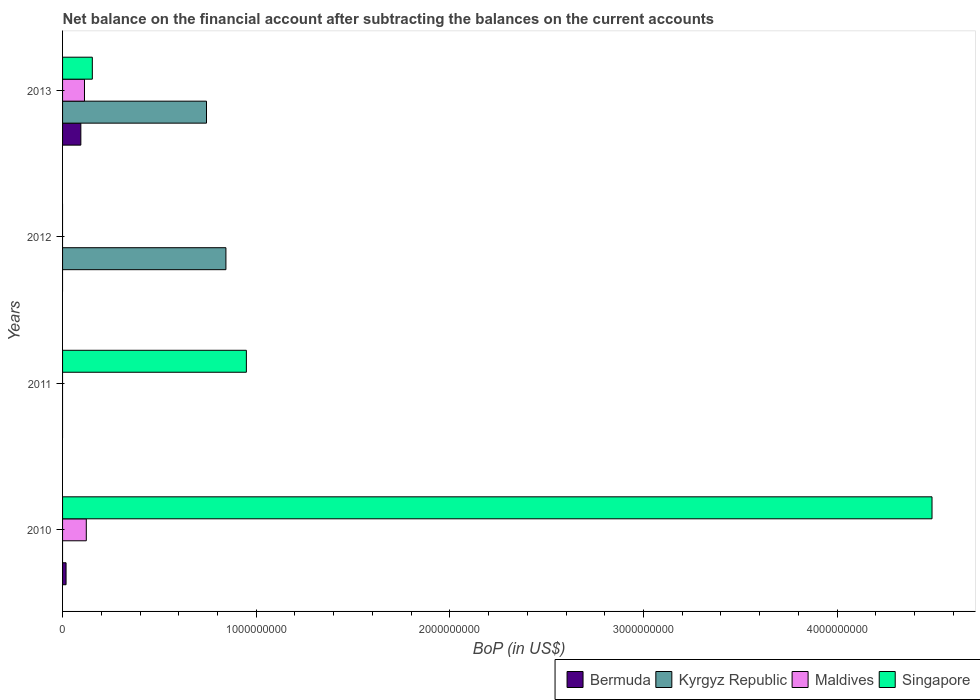How many different coloured bars are there?
Ensure brevity in your answer.  4. Are the number of bars per tick equal to the number of legend labels?
Offer a very short reply. No. How many bars are there on the 1st tick from the bottom?
Make the answer very short. 3. What is the label of the 3rd group of bars from the top?
Your answer should be very brief. 2011. What is the Balance of Payments in Kyrgyz Republic in 2013?
Keep it short and to the point. 7.43e+08. Across all years, what is the maximum Balance of Payments in Singapore?
Give a very brief answer. 4.49e+09. In which year was the Balance of Payments in Singapore maximum?
Offer a very short reply. 2010. What is the total Balance of Payments in Bermuda in the graph?
Provide a succinct answer. 1.12e+08. What is the difference between the Balance of Payments in Kyrgyz Republic in 2012 and that in 2013?
Give a very brief answer. 1.00e+08. What is the difference between the Balance of Payments in Maldives in 2010 and the Balance of Payments in Bermuda in 2011?
Offer a very short reply. 1.23e+08. What is the average Balance of Payments in Maldives per year?
Offer a terse response. 5.89e+07. In the year 2013, what is the difference between the Balance of Payments in Singapore and Balance of Payments in Kyrgyz Republic?
Offer a very short reply. -5.90e+08. In how many years, is the Balance of Payments in Maldives greater than 2200000000 US$?
Offer a terse response. 0. What is the ratio of the Balance of Payments in Singapore in 2011 to that in 2013?
Offer a terse response. 6.18. What is the difference between the highest and the second highest Balance of Payments in Singapore?
Make the answer very short. 3.54e+09. What is the difference between the highest and the lowest Balance of Payments in Singapore?
Ensure brevity in your answer.  4.49e+09. In how many years, is the Balance of Payments in Kyrgyz Republic greater than the average Balance of Payments in Kyrgyz Republic taken over all years?
Offer a very short reply. 2. Is it the case that in every year, the sum of the Balance of Payments in Bermuda and Balance of Payments in Maldives is greater than the sum of Balance of Payments in Singapore and Balance of Payments in Kyrgyz Republic?
Your answer should be very brief. No. Are all the bars in the graph horizontal?
Make the answer very short. Yes. Are the values on the major ticks of X-axis written in scientific E-notation?
Ensure brevity in your answer.  No. Does the graph contain grids?
Ensure brevity in your answer.  No. Where does the legend appear in the graph?
Your answer should be very brief. Bottom right. How many legend labels are there?
Keep it short and to the point. 4. How are the legend labels stacked?
Offer a very short reply. Horizontal. What is the title of the graph?
Keep it short and to the point. Net balance on the financial account after subtracting the balances on the current accounts. What is the label or title of the X-axis?
Provide a succinct answer. BoP (in US$). What is the label or title of the Y-axis?
Offer a very short reply. Years. What is the BoP (in US$) in Bermuda in 2010?
Offer a terse response. 1.80e+07. What is the BoP (in US$) of Maldives in 2010?
Offer a very short reply. 1.23e+08. What is the BoP (in US$) in Singapore in 2010?
Give a very brief answer. 4.49e+09. What is the BoP (in US$) in Kyrgyz Republic in 2011?
Offer a terse response. 0. What is the BoP (in US$) in Maldives in 2011?
Make the answer very short. 0. What is the BoP (in US$) of Singapore in 2011?
Make the answer very short. 9.49e+08. What is the BoP (in US$) of Bermuda in 2012?
Offer a terse response. 0. What is the BoP (in US$) in Kyrgyz Republic in 2012?
Your answer should be very brief. 8.44e+08. What is the BoP (in US$) of Maldives in 2012?
Your answer should be very brief. 0. What is the BoP (in US$) of Singapore in 2012?
Give a very brief answer. 0. What is the BoP (in US$) in Bermuda in 2013?
Give a very brief answer. 9.44e+07. What is the BoP (in US$) in Kyrgyz Republic in 2013?
Your answer should be compact. 7.43e+08. What is the BoP (in US$) of Maldives in 2013?
Your answer should be compact. 1.13e+08. What is the BoP (in US$) in Singapore in 2013?
Your response must be concise. 1.54e+08. Across all years, what is the maximum BoP (in US$) in Bermuda?
Your response must be concise. 9.44e+07. Across all years, what is the maximum BoP (in US$) in Kyrgyz Republic?
Your answer should be compact. 8.44e+08. Across all years, what is the maximum BoP (in US$) in Maldives?
Give a very brief answer. 1.23e+08. Across all years, what is the maximum BoP (in US$) of Singapore?
Offer a very short reply. 4.49e+09. Across all years, what is the minimum BoP (in US$) in Kyrgyz Republic?
Keep it short and to the point. 0. What is the total BoP (in US$) of Bermuda in the graph?
Offer a very short reply. 1.12e+08. What is the total BoP (in US$) of Kyrgyz Republic in the graph?
Make the answer very short. 1.59e+09. What is the total BoP (in US$) in Maldives in the graph?
Provide a succinct answer. 2.36e+08. What is the total BoP (in US$) of Singapore in the graph?
Give a very brief answer. 5.59e+09. What is the difference between the BoP (in US$) of Singapore in 2010 and that in 2011?
Ensure brevity in your answer.  3.54e+09. What is the difference between the BoP (in US$) in Bermuda in 2010 and that in 2013?
Give a very brief answer. -7.64e+07. What is the difference between the BoP (in US$) in Maldives in 2010 and that in 2013?
Your answer should be very brief. 9.42e+06. What is the difference between the BoP (in US$) of Singapore in 2010 and that in 2013?
Provide a short and direct response. 4.34e+09. What is the difference between the BoP (in US$) of Singapore in 2011 and that in 2013?
Ensure brevity in your answer.  7.96e+08. What is the difference between the BoP (in US$) in Kyrgyz Republic in 2012 and that in 2013?
Offer a very short reply. 1.00e+08. What is the difference between the BoP (in US$) of Bermuda in 2010 and the BoP (in US$) of Singapore in 2011?
Your response must be concise. -9.31e+08. What is the difference between the BoP (in US$) in Maldives in 2010 and the BoP (in US$) in Singapore in 2011?
Your answer should be very brief. -8.27e+08. What is the difference between the BoP (in US$) of Bermuda in 2010 and the BoP (in US$) of Kyrgyz Republic in 2012?
Keep it short and to the point. -8.26e+08. What is the difference between the BoP (in US$) of Bermuda in 2010 and the BoP (in US$) of Kyrgyz Republic in 2013?
Your answer should be very brief. -7.25e+08. What is the difference between the BoP (in US$) of Bermuda in 2010 and the BoP (in US$) of Maldives in 2013?
Offer a very short reply. -9.51e+07. What is the difference between the BoP (in US$) in Bermuda in 2010 and the BoP (in US$) in Singapore in 2013?
Provide a succinct answer. -1.36e+08. What is the difference between the BoP (in US$) of Maldives in 2010 and the BoP (in US$) of Singapore in 2013?
Give a very brief answer. -3.11e+07. What is the difference between the BoP (in US$) in Kyrgyz Republic in 2012 and the BoP (in US$) in Maldives in 2013?
Make the answer very short. 7.30e+08. What is the difference between the BoP (in US$) in Kyrgyz Republic in 2012 and the BoP (in US$) in Singapore in 2013?
Make the answer very short. 6.90e+08. What is the average BoP (in US$) in Bermuda per year?
Ensure brevity in your answer.  2.81e+07. What is the average BoP (in US$) of Kyrgyz Republic per year?
Make the answer very short. 3.97e+08. What is the average BoP (in US$) in Maldives per year?
Your response must be concise. 5.89e+07. What is the average BoP (in US$) of Singapore per year?
Provide a succinct answer. 1.40e+09. In the year 2010, what is the difference between the BoP (in US$) in Bermuda and BoP (in US$) in Maldives?
Offer a very short reply. -1.05e+08. In the year 2010, what is the difference between the BoP (in US$) of Bermuda and BoP (in US$) of Singapore?
Your response must be concise. -4.47e+09. In the year 2010, what is the difference between the BoP (in US$) of Maldives and BoP (in US$) of Singapore?
Make the answer very short. -4.37e+09. In the year 2013, what is the difference between the BoP (in US$) of Bermuda and BoP (in US$) of Kyrgyz Republic?
Keep it short and to the point. -6.49e+08. In the year 2013, what is the difference between the BoP (in US$) of Bermuda and BoP (in US$) of Maldives?
Ensure brevity in your answer.  -1.87e+07. In the year 2013, what is the difference between the BoP (in US$) in Bermuda and BoP (in US$) in Singapore?
Provide a succinct answer. -5.93e+07. In the year 2013, what is the difference between the BoP (in US$) of Kyrgyz Republic and BoP (in US$) of Maldives?
Your response must be concise. 6.30e+08. In the year 2013, what is the difference between the BoP (in US$) of Kyrgyz Republic and BoP (in US$) of Singapore?
Your answer should be very brief. 5.90e+08. In the year 2013, what is the difference between the BoP (in US$) of Maldives and BoP (in US$) of Singapore?
Provide a succinct answer. -4.05e+07. What is the ratio of the BoP (in US$) in Singapore in 2010 to that in 2011?
Provide a succinct answer. 4.73. What is the ratio of the BoP (in US$) in Bermuda in 2010 to that in 2013?
Offer a very short reply. 0.19. What is the ratio of the BoP (in US$) of Maldives in 2010 to that in 2013?
Ensure brevity in your answer.  1.08. What is the ratio of the BoP (in US$) of Singapore in 2010 to that in 2013?
Offer a very short reply. 29.22. What is the ratio of the BoP (in US$) in Singapore in 2011 to that in 2013?
Give a very brief answer. 6.18. What is the ratio of the BoP (in US$) in Kyrgyz Republic in 2012 to that in 2013?
Your answer should be very brief. 1.13. What is the difference between the highest and the second highest BoP (in US$) in Singapore?
Offer a very short reply. 3.54e+09. What is the difference between the highest and the lowest BoP (in US$) of Bermuda?
Provide a succinct answer. 9.44e+07. What is the difference between the highest and the lowest BoP (in US$) in Kyrgyz Republic?
Give a very brief answer. 8.44e+08. What is the difference between the highest and the lowest BoP (in US$) in Maldives?
Your answer should be compact. 1.23e+08. What is the difference between the highest and the lowest BoP (in US$) of Singapore?
Give a very brief answer. 4.49e+09. 